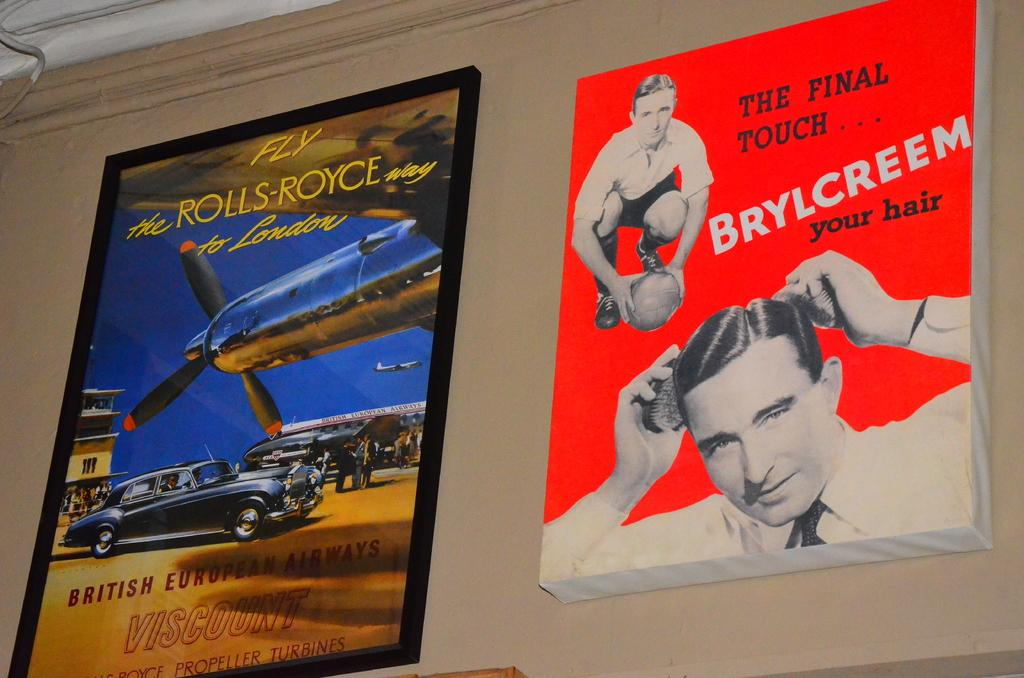<image>
Summarize the visual content of the image. an advertisement for Brylcreem is hanging beside an ad for flying Rolls Royce 